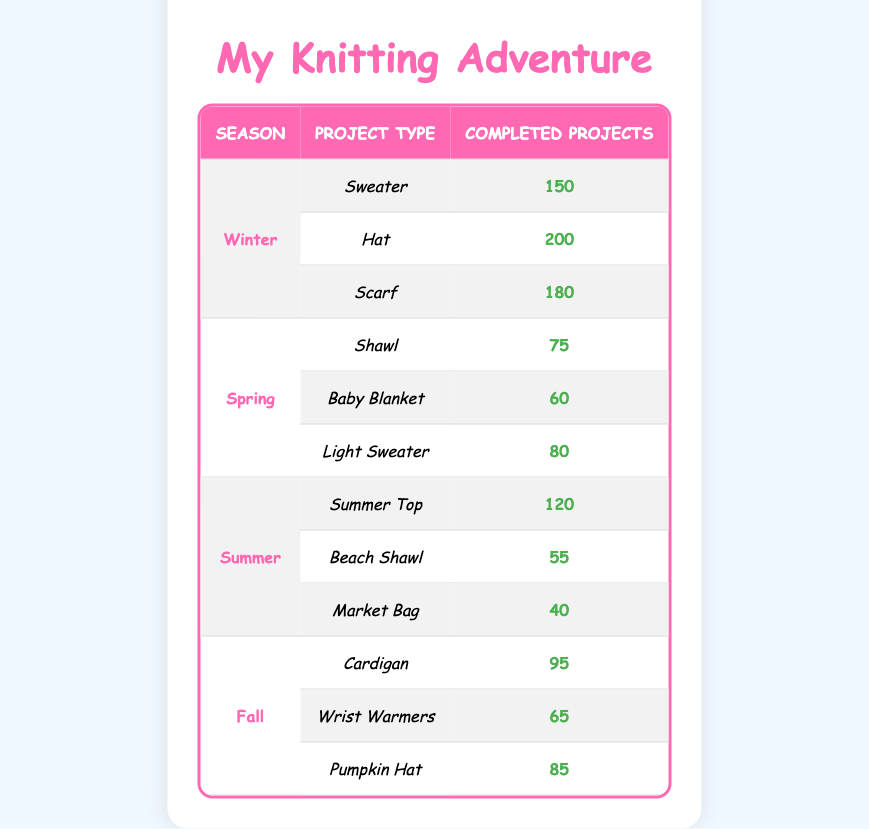What is the total number of completed projects in Winter? In Winter, we have three completed projects: Sweater (150), Hat (200), and Scarf (180). To find the total, we add these numbers: 150 + 200 + 180 = 530.
Answer: 530 Which project type had the least completed projects in Spring? In Spring, there are three project types: Shawl (75), Baby Blanket (60), and Light Sweater (80). Comparing the numbers, Baby Blanket is the smallest: 60.
Answer: Baby Blanket Is the number of completed projects for Summer Hats greater than 70? In the table, there are no projects categorized as Summer Hats. So, based on the available data, we cannot determine if any have greater completed projects than 70. Therefore, the answer is no.
Answer: No What is the average number of completed projects in Fall? In Fall, there are three project types: Cardigan (95), Wrist Warmers (65), and Pumpkin Hat (85). To find the average, we first sum these projects: 95 + 65 + 85 = 245. Then, divide the sum by the number of projects (3): 245 / 3 = 81.67.
Answer: 81.67 Which season had the highest number of completed knitting projects overall? To identify which season had the most completed projects, we need to calculate the total for each season: Winter (530), Spring (215), Summer (215), and Fall (245). Winter has the highest total as 530 is greater than the totals for the other seasons.
Answer: Winter What is the difference in completed projects between the most popular project in Winter and the least popular in Spring? In Winter, the most completed project is the Hat (200), and the least in Spring is the Baby Blanket (60). To find the difference, we subtract: 200 - 60 = 140.
Answer: 140 How many projects had over 100 completed projects across all seasons? First, identify projects with over 100 completed projects: Winter - Sweater (150) and Hat (200), Summer - Summer Top (120). In total, there are 3 projects fitting this criterion.
Answer: 3 Is it true that the Light Sweater was completed more than the Beach Shawl? According to the data, the Light Sweater has 80 completed projects while the Beach Shawl only has 55. Therefore, the statement is true.
Answer: Yes 